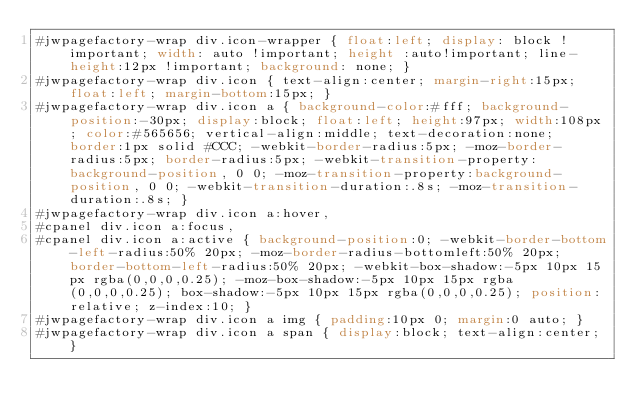Convert code to text. <code><loc_0><loc_0><loc_500><loc_500><_CSS_>#jwpagefactory-wrap div.icon-wrapper { float:left; display: block !important; width: auto !important; height :auto!important; line-height:12px !important; background: none; }
#jwpagefactory-wrap div.icon { text-align:center; margin-right:15px; float:left; margin-bottom:15px; }
#jwpagefactory-wrap div.icon a { background-color:#fff; background-position:-30px; display:block; float:left; height:97px; width:108px; color:#565656; vertical-align:middle; text-decoration:none; border:1px solid #CCC; -webkit-border-radius:5px; -moz-border-radius:5px; border-radius:5px; -webkit-transition-property:background-position, 0 0; -moz-transition-property:background-position, 0 0; -webkit-transition-duration:.8s; -moz-transition-duration:.8s; }
#jwpagefactory-wrap div.icon a:hover,
#cpanel div.icon a:focus,
#cpanel div.icon a:active { background-position:0; -webkit-border-bottom-left-radius:50% 20px; -moz-border-radius-bottomleft:50% 20px; border-bottom-left-radius:50% 20px; -webkit-box-shadow:-5px 10px 15px rgba(0,0,0,0.25); -moz-box-shadow:-5px 10px 15px rgba(0,0,0,0.25); box-shadow:-5px 10px 15px rgba(0,0,0,0.25); position:relative; z-index:10; }
#jwpagefactory-wrap div.icon a img { padding:10px 0; margin:0 auto; }
#jwpagefactory-wrap div.icon a span { display:block; text-align:center; }</code> 